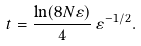Convert formula to latex. <formula><loc_0><loc_0><loc_500><loc_500>t = \frac { \ln ( 8 N \varepsilon ) } { 4 } \, \varepsilon ^ { - 1 / 2 } .</formula> 